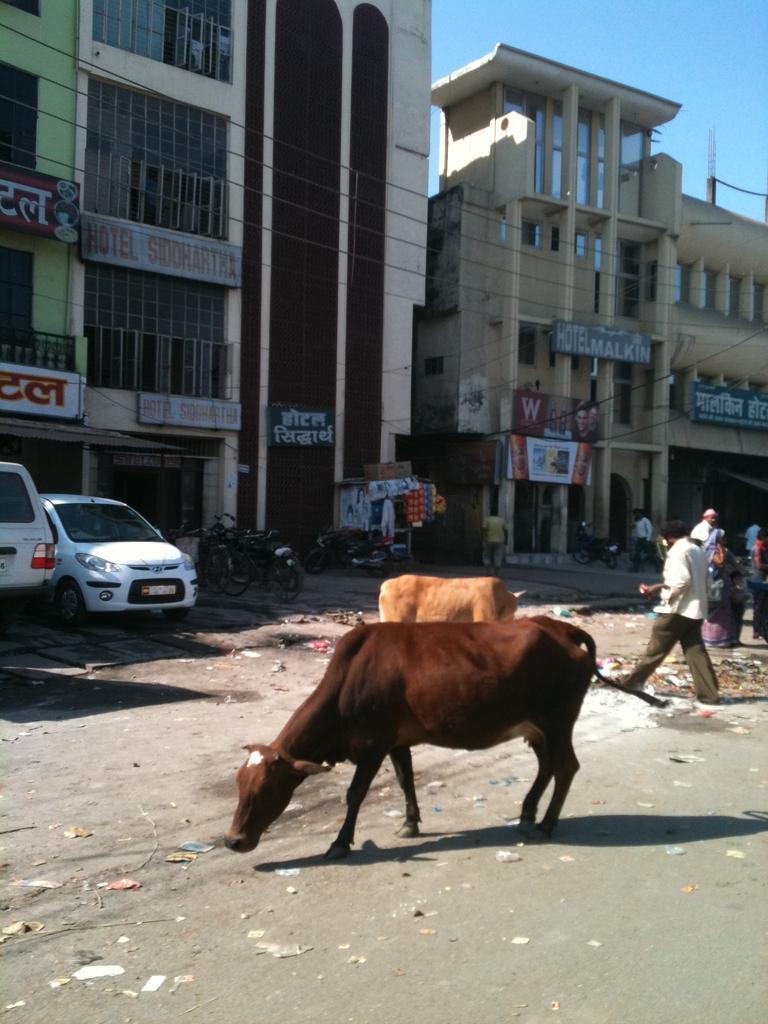Describe this image in one or two sentences. This is the picture of a road. In the foreground there are two cows standing on the road and there are group of people on the road. At the back there are vehicles on the road and there are buildings and there are hoardings on the buildings. At the top there is sky and there are wires. At the bottom there is a road and there is a garbage on the road. 